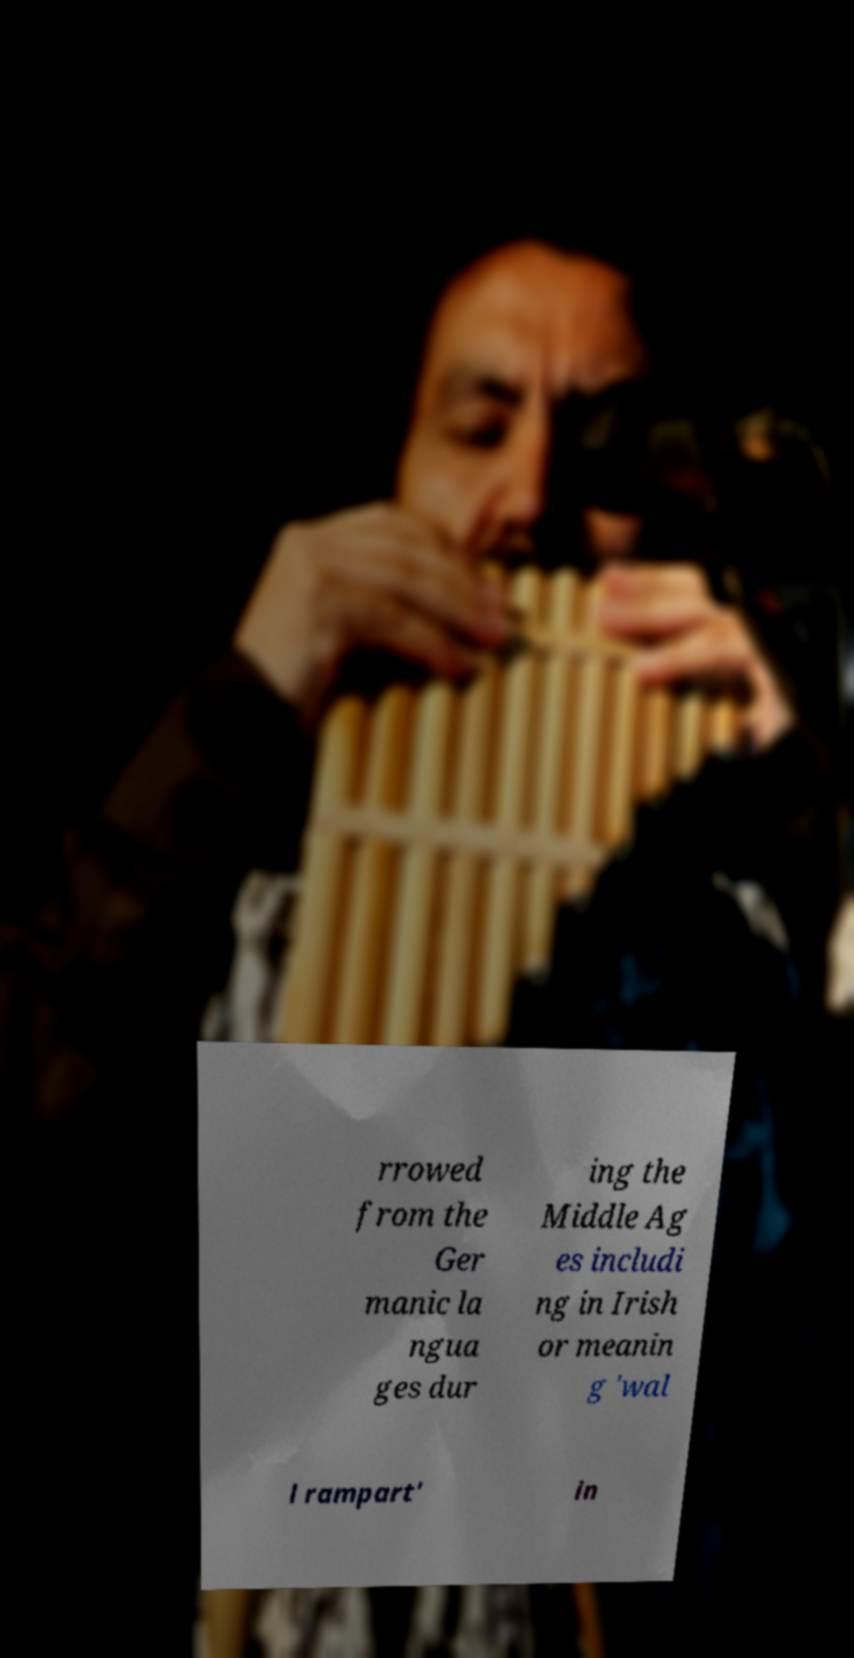What messages or text are displayed in this image? I need them in a readable, typed format. rrowed from the Ger manic la ngua ges dur ing the Middle Ag es includi ng in Irish or meanin g 'wal l rampart' in 